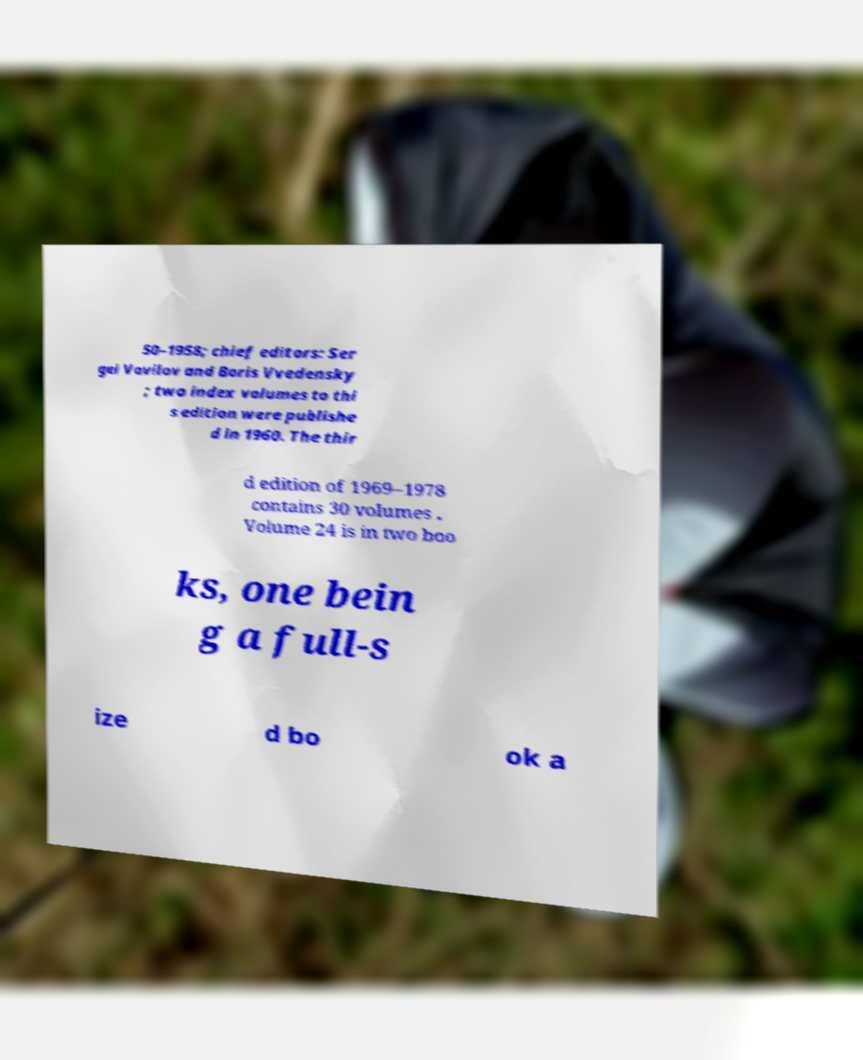Could you assist in decoding the text presented in this image and type it out clearly? 50–1958; chief editors: Ser gei Vavilov and Boris Vvedensky ; two index volumes to thi s edition were publishe d in 1960. The thir d edition of 1969–1978 contains 30 volumes . Volume 24 is in two boo ks, one bein g a full-s ize d bo ok a 